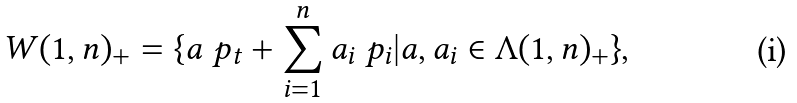<formula> <loc_0><loc_0><loc_500><loc_500>W ( 1 , n ) _ { + } = \{ a \ p _ { t } + \sum _ { i = 1 } ^ { n } a _ { i } \ p _ { i } | a , a _ { i } \in \Lambda ( 1 , n ) _ { + } \} ,</formula> 